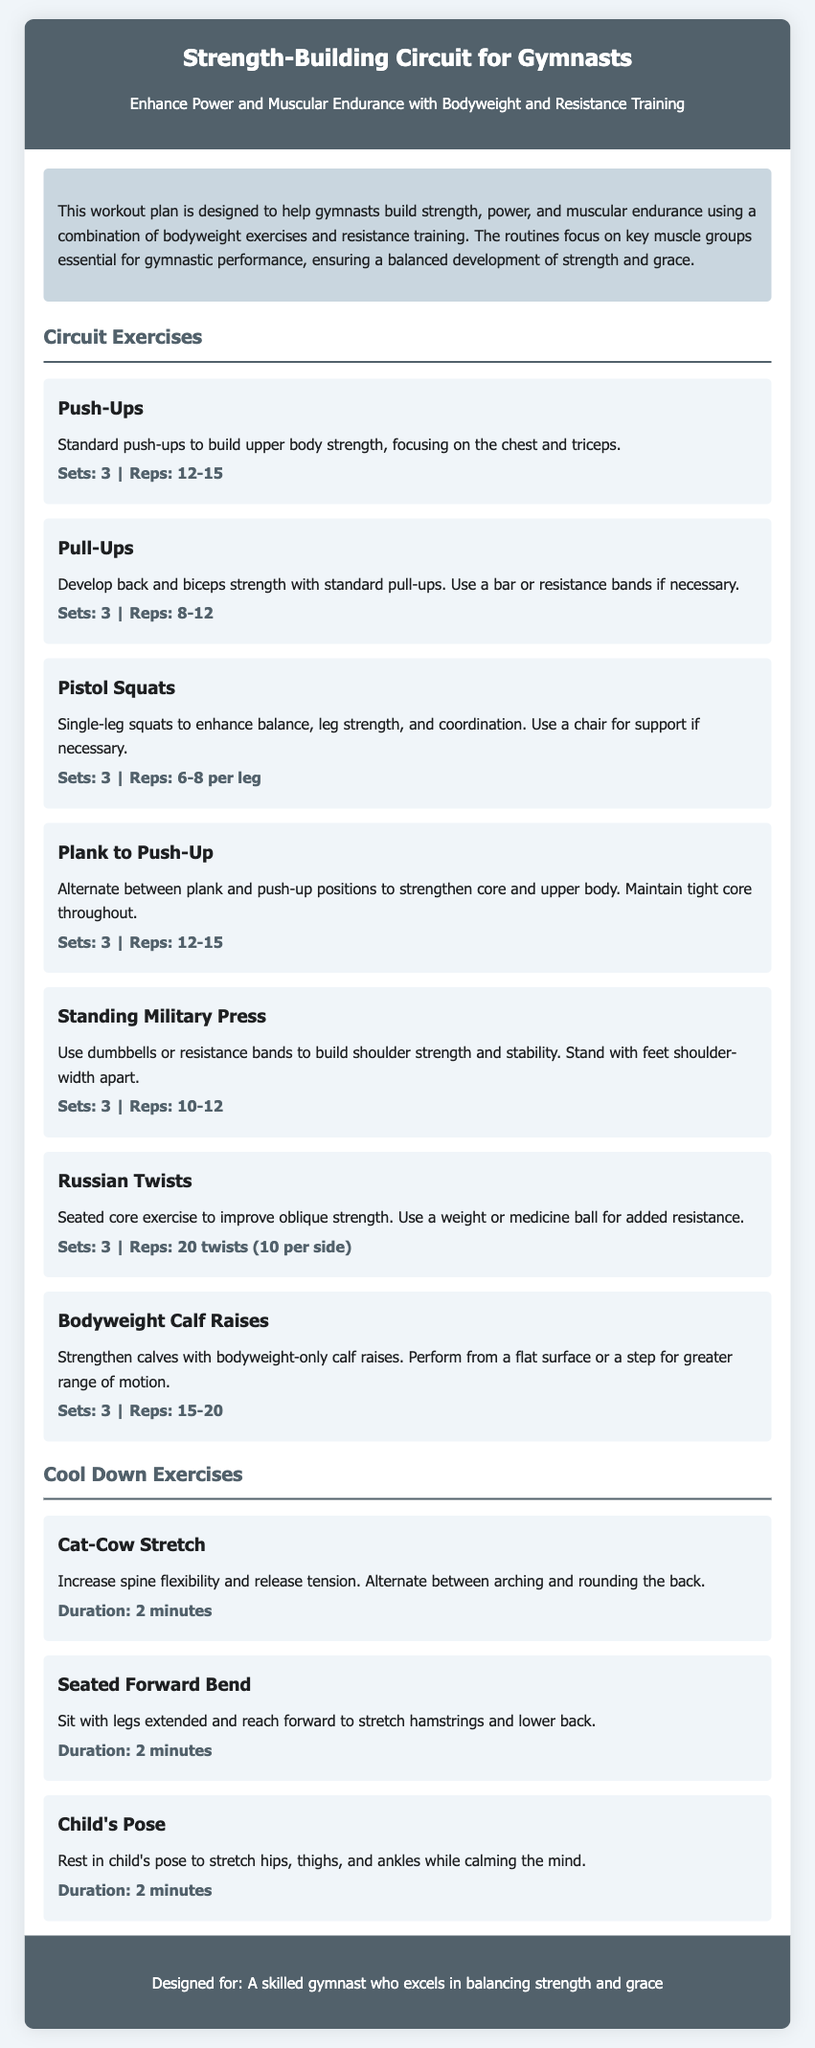What is the title of the document? The title of the document is found in the header section, stating the main topic of the workout plan.
Answer: Strength-Building Circuit for Gymnasts How many exercises are listed in the circuit? By counting the exercises in the "Circuit Exercises" section, we find the total number available to gymnasts.
Answer: 7 What is the duration of the Cat-Cow Stretch? The duration is mentioned in the cool-down section for this specific exercise.
Answer: 2 minutes What muscle groups do Push-Ups focus on? The exercise description specifically mentions the areas targeted by performing standard push-ups.
Answer: Chest and triceps What type of resistance is used in the Standing Military Press? The document specifies the equipment options that can be used during this exercise.
Answer: Dumbbells or resistance bands What is the primary benefit of the Russian Twists exercise? The explanation for the Russian Twists highlights what the exercise aims to improve for gymnasts.
Answer: Improve oblique strength 